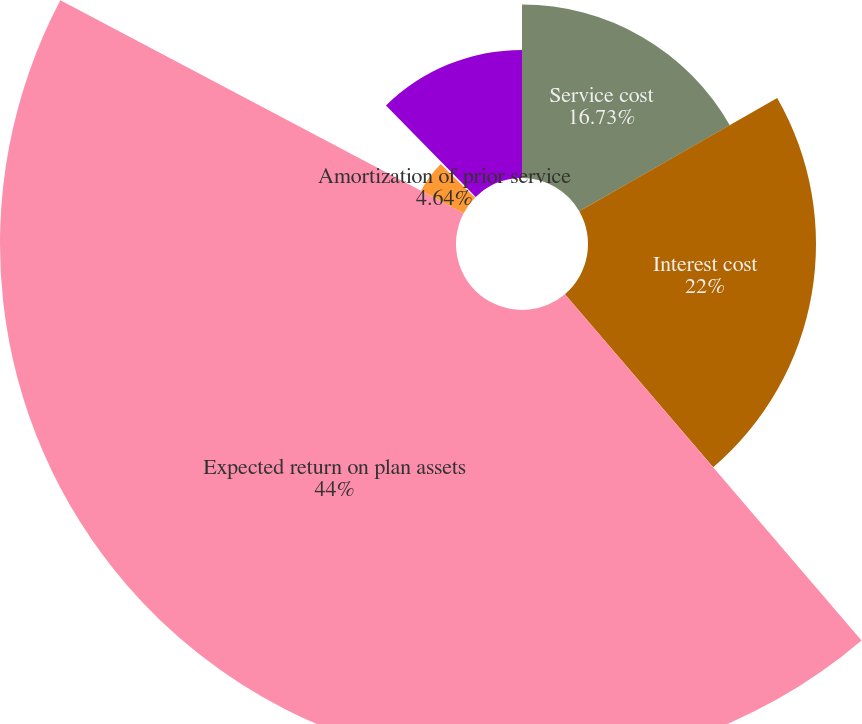Convert chart to OTSL. <chart><loc_0><loc_0><loc_500><loc_500><pie_chart><fcel>Service cost<fcel>Interest cost<fcel>Expected return on plan assets<fcel>Amortization of prior service<fcel>Recognized net actuarial<fcel>Net periodic benefit cost<nl><fcel>16.73%<fcel>22.0%<fcel>44.0%<fcel>4.64%<fcel>0.27%<fcel>12.36%<nl></chart> 